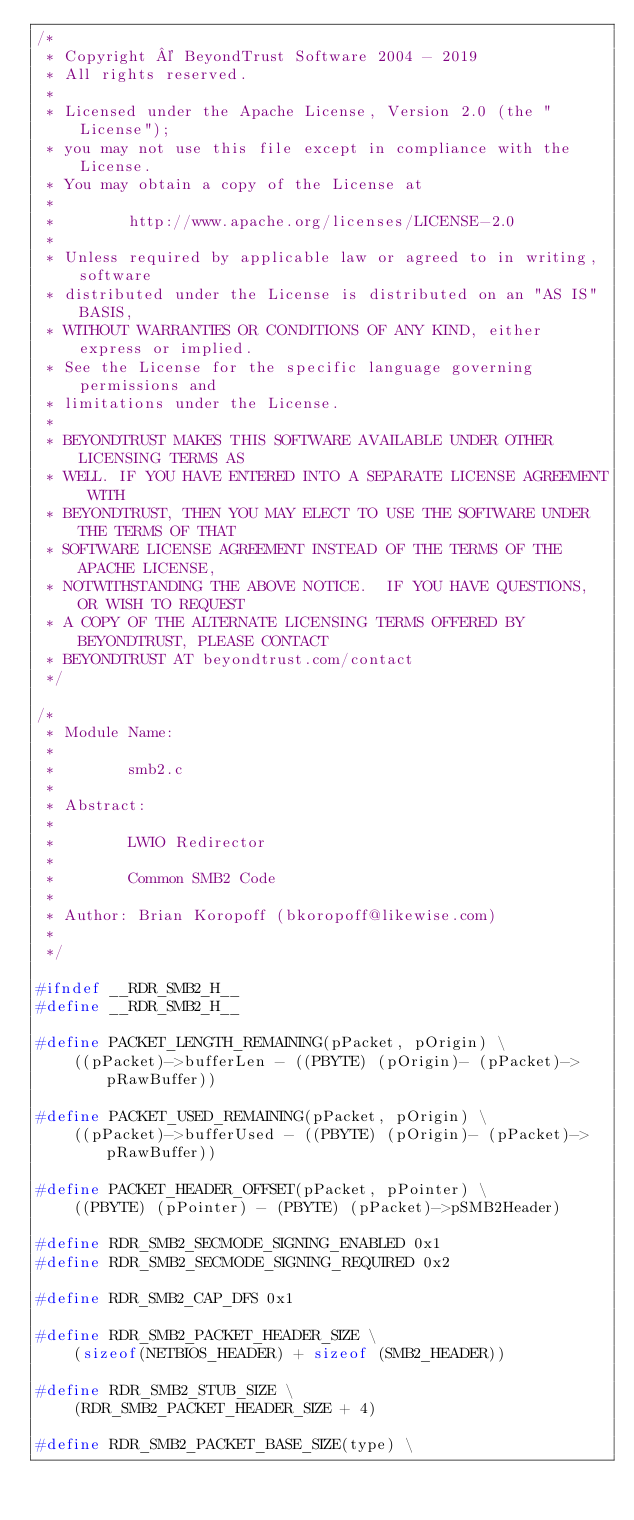Convert code to text. <code><loc_0><loc_0><loc_500><loc_500><_C_>/*
 * Copyright © BeyondTrust Software 2004 - 2019
 * All rights reserved.
 *
 * Licensed under the Apache License, Version 2.0 (the "License");
 * you may not use this file except in compliance with the License.
 * You may obtain a copy of the License at
 *
 *        http://www.apache.org/licenses/LICENSE-2.0
 *
 * Unless required by applicable law or agreed to in writing, software
 * distributed under the License is distributed on an "AS IS" BASIS,
 * WITHOUT WARRANTIES OR CONDITIONS OF ANY KIND, either express or implied.
 * See the License for the specific language governing permissions and
 * limitations under the License.
 *
 * BEYONDTRUST MAKES THIS SOFTWARE AVAILABLE UNDER OTHER LICENSING TERMS AS
 * WELL. IF YOU HAVE ENTERED INTO A SEPARATE LICENSE AGREEMENT WITH
 * BEYONDTRUST, THEN YOU MAY ELECT TO USE THE SOFTWARE UNDER THE TERMS OF THAT
 * SOFTWARE LICENSE AGREEMENT INSTEAD OF THE TERMS OF THE APACHE LICENSE,
 * NOTWITHSTANDING THE ABOVE NOTICE.  IF YOU HAVE QUESTIONS, OR WISH TO REQUEST
 * A COPY OF THE ALTERNATE LICENSING TERMS OFFERED BY BEYONDTRUST, PLEASE CONTACT
 * BEYONDTRUST AT beyondtrust.com/contact
 */

/*
 * Module Name:
 *
 *        smb2.c
 *
 * Abstract:
 *
 *        LWIO Redirector
 *
 *        Common SMB2 Code
 *
 * Author: Brian Koropoff (bkoropoff@likewise.com)
 *
 */

#ifndef __RDR_SMB2_H__
#define __RDR_SMB2_H__

#define PACKET_LENGTH_REMAINING(pPacket, pOrigin) \
    ((pPacket)->bufferLen - ((PBYTE) (pOrigin)- (pPacket)->pRawBuffer))

#define PACKET_USED_REMAINING(pPacket, pOrigin) \
    ((pPacket)->bufferUsed - ((PBYTE) (pOrigin)- (pPacket)->pRawBuffer))

#define PACKET_HEADER_OFFSET(pPacket, pPointer) \
    ((PBYTE) (pPointer) - (PBYTE) (pPacket)->pSMB2Header)

#define RDR_SMB2_SECMODE_SIGNING_ENABLED 0x1
#define RDR_SMB2_SECMODE_SIGNING_REQUIRED 0x2

#define RDR_SMB2_CAP_DFS 0x1

#define RDR_SMB2_PACKET_HEADER_SIZE \
    (sizeof(NETBIOS_HEADER) + sizeof (SMB2_HEADER))

#define RDR_SMB2_STUB_SIZE \
    (RDR_SMB2_PACKET_HEADER_SIZE + 4)

#define RDR_SMB2_PACKET_BASE_SIZE(type) \</code> 